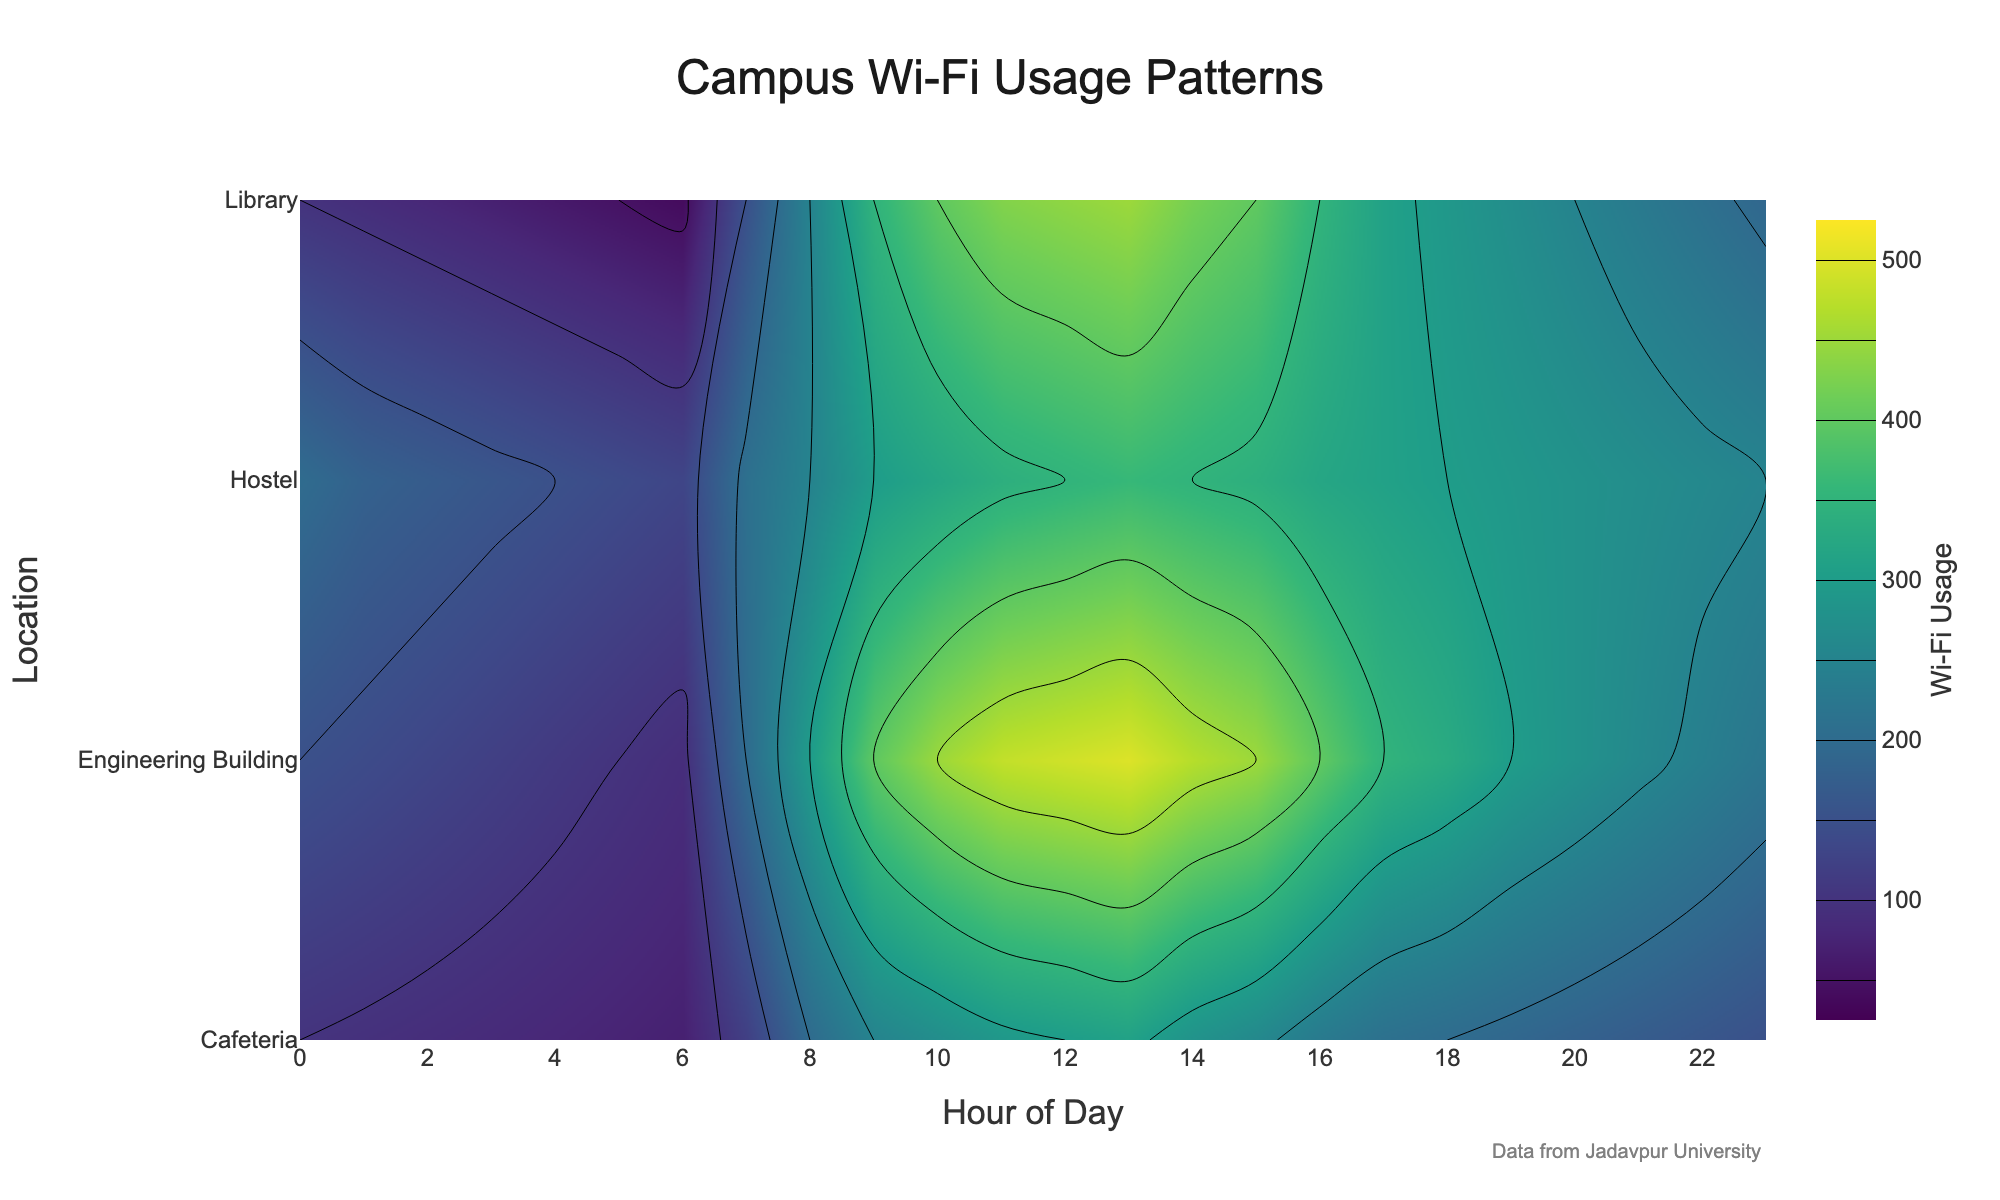What is the title of the contour plot? The title of a plot usually appears at the top. In this plot, it reads 'Campus Wi-Fi Usage Patterns'.
Answer: Campus Wi-Fi Usage Patterns Which location has the highest peak usage, and at what time does it occur? To determine the peak usage, we look for the highest contour values. In the plot, the highest usage is in the Engineering Building at 1 PM (13:00) with 500 users.
Answer: Engineering Building at 1 PM (13:00) At what time does the Library experience its maximum Wi-Fi usage? By observing the peak contour in the Library row, the maximum Wi-Fi usage in the Library is at 1 PM (13:00) with 450 users.
Answer: 1 PM (13:00) Compare the Wi-Fi usage in the Cafeteria and Hostel at 10 AM. Which location has higher usage and by how much? At 10 AM, look at the contour values for both Cafeteria and Hostel. Cafeteria has 270 users, while Hostel has 320 users. The difference is 320 - 270 = 50. Thus, the Hostel usage is higher by 50 users.
Answer: Hostel by 50 users What is the range of Wi-Fi usage values displayed on the plot's colorbar? The colorbar typically shows the range of values represented by colors. The contour plot’s colorbar ranges from 50 to 500.
Answer: 50 to 500 How does the Wi-Fi usage in Engineering Building change from 6 AM to 8 AM? From the plot, at 6 AM the usage is 90, and it increases to 200 by 7 AM and further to 300 by 8 AM. Thus, the usage rises from 90 to 300 between 6 AM and 8 AM.
Answer: Increases from 90 to 300 Identify a significant usage trend in the Hostel location across the day. Examine the contour lines in the Hostel row to find trends. Usage in the Hostel starts high at 12 AM (midnight) with 200 users, then gradually decreases to 130 by 6 AM, rises again to a late peak of 360 users at 1 PM, and then gradually drops to 250 by 11 PM.
Answer: Peaks at 1 PM and decreases after Which location experiences the least variation in Wi-Fi usage throughout the day? Compare the spread of contour values for each location. The Cafeteria has the least variation as its values remain relatively close together throughout the day.
Answer: Cafeteria What time span has the lowest usage in the Library? Identify the lowest contour values in the Library's row. The lowest usage of 40 occurs at 6 AM, representing the time with minimal usage from late night to early morning.
Answer: Early morning (6 AM) Does the Engineering Building have higher or lower Wi-Fi usage than the Library at 3 PM, and by how much? At 3 PM, the plot shows 450 users in the Engineering Building and 400 users in the Library. The difference is 450 - 400 = 50, with Engineering Building having higher usage by 50 users.
Answer: Higher by 50 users 